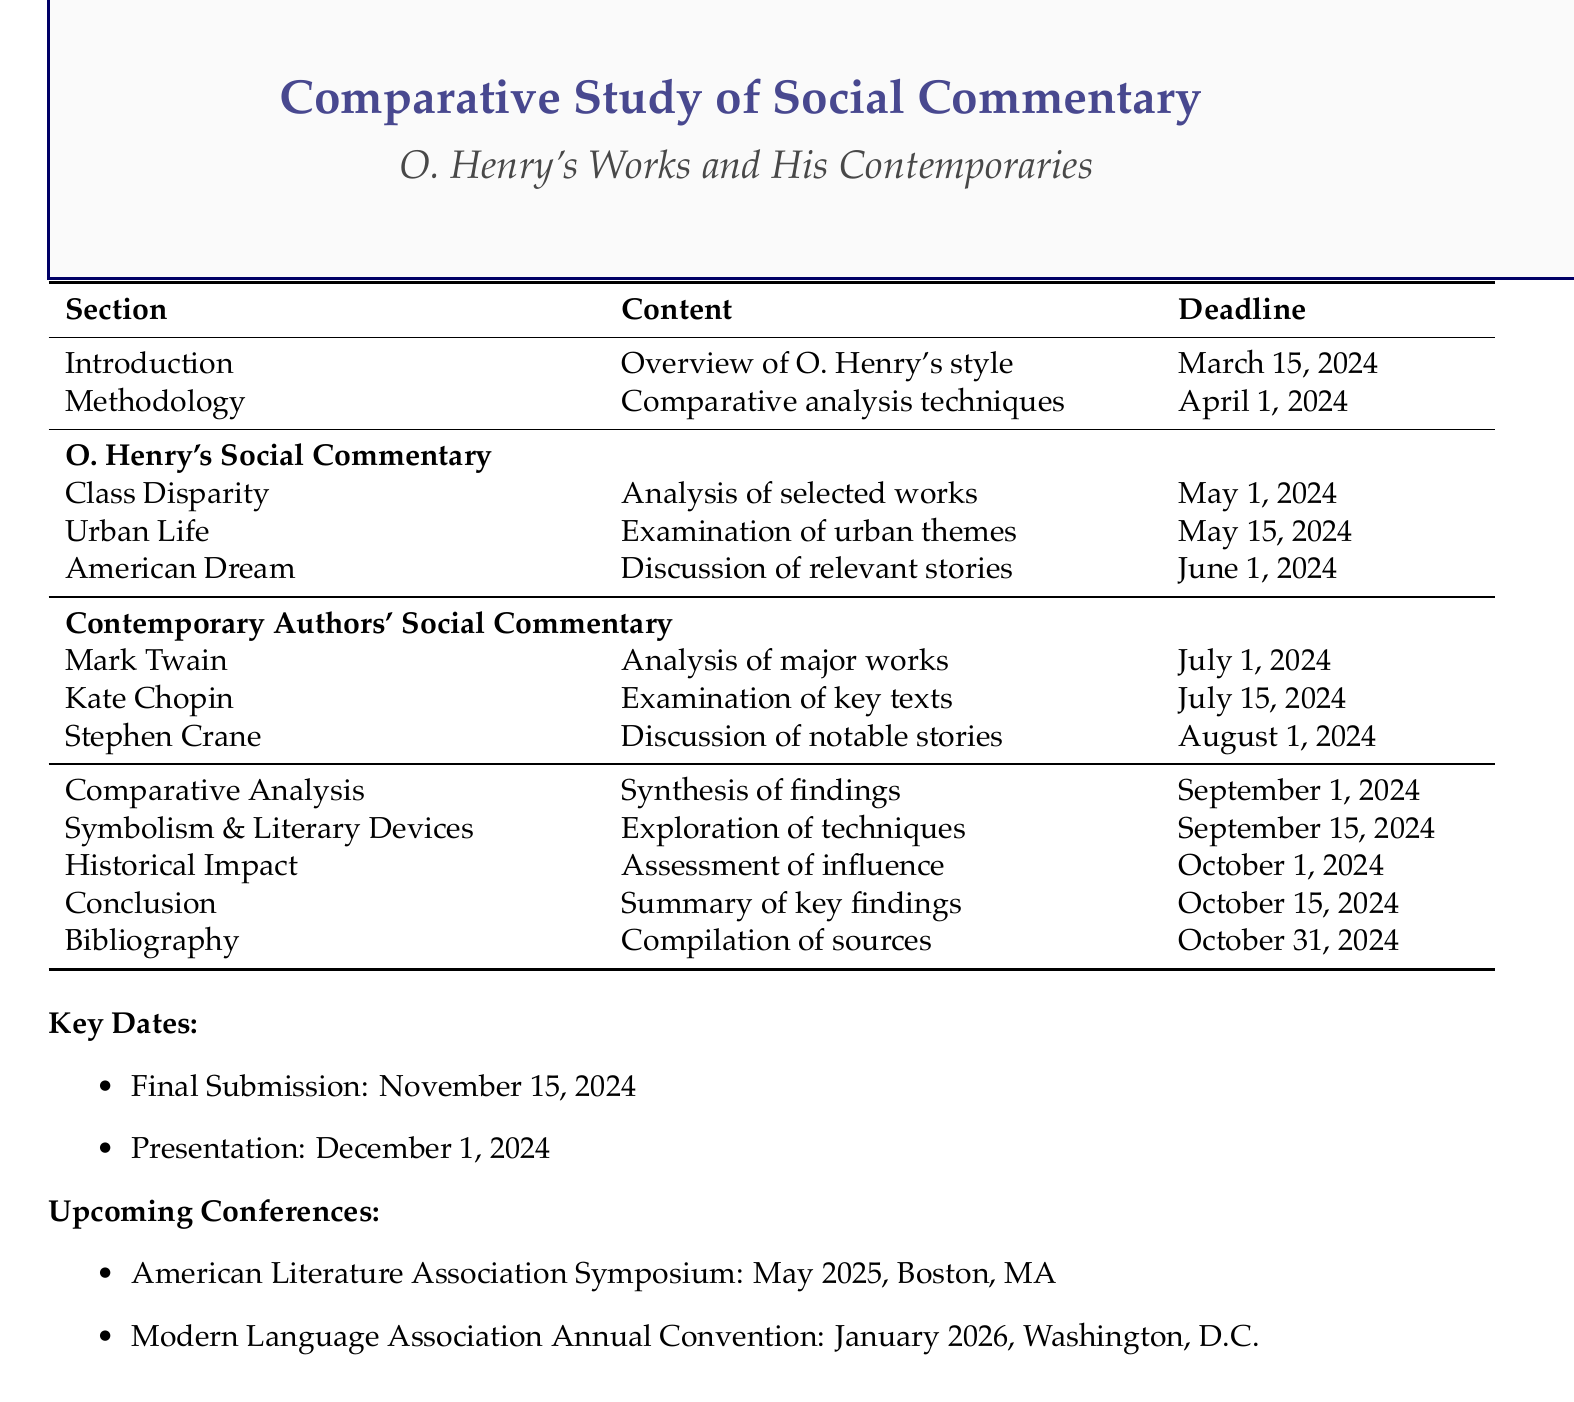What is the title of the document? The title of the document is stated in the header of the rendered document.
Answer: Comparative Study of Social Commentary in O. Henry's Works and His Contemporaries When is the final submission deadline? The final submission deadline is specified in the key dates section of the document.
Answer: November 15, 2024 Which section discusses 'Class Disparity'? The section focusing on 'Class Disparity' is mentioned under O. Henry's social commentary, detailing specific analyses.
Answer: O. Henry's Social Commentary What are the deadlines for sections on Contemporary Authors' Social Commentary? The deadlines are listed under the specific subsections, indicating when each analysis should be completed.
Answer: July 1, 2024, July 15, 2024, August 1, 2024 What is the content of the 'Methodology' section? The content for the 'Methodology' section outlines how the comparative analysis will be conducted and what criteria will be used.
Answer: Outline of comparative analysis techniques and selection criteria for contemporary authors Which author is analyzed in the context of 'The Adventures of Huckleberry Finn'? This information can be found in the segment about contemporary authors' social commentary, indicating which works are being analyzed.
Answer: Mark Twain What is the main focus of the 'Comparative Analysis' section? The main focus is summarized in the section title and content description.
Answer: Synthesis of findings, highlighting similarities and differences in social commentary approaches What is the date and location for the upcoming American Literature Association Symposium? This is detailed in the section for upcoming conferences, specifying when and where it will take place.
Answer: May 2025, Boston, Massachusetts 